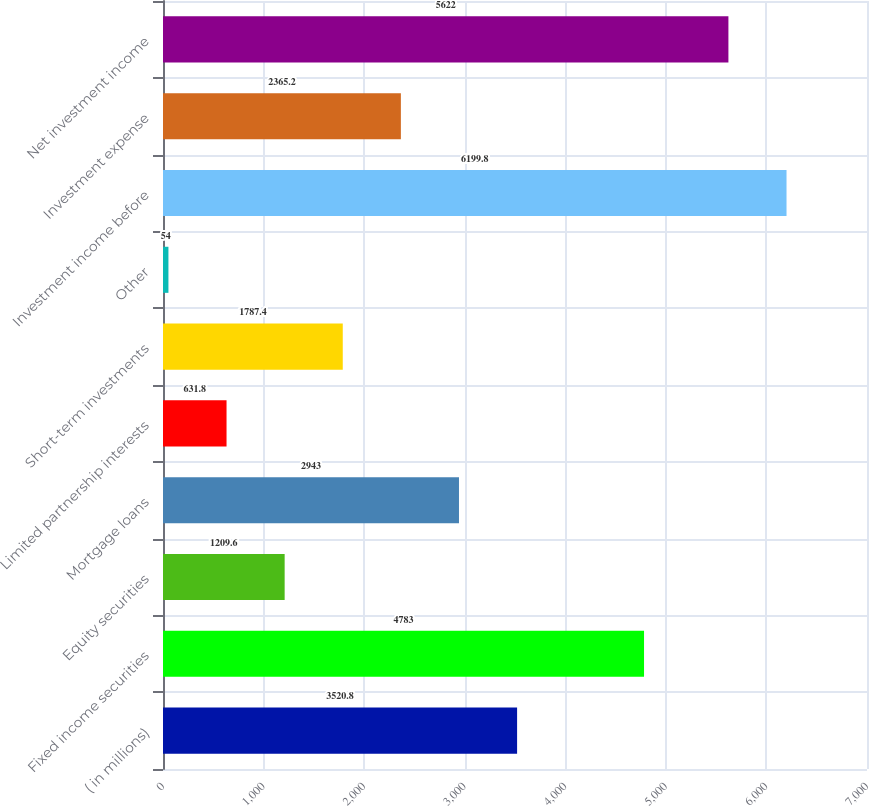Convert chart to OTSL. <chart><loc_0><loc_0><loc_500><loc_500><bar_chart><fcel>( in millions)<fcel>Fixed income securities<fcel>Equity securities<fcel>Mortgage loans<fcel>Limited partnership interests<fcel>Short-term investments<fcel>Other<fcel>Investment income before<fcel>Investment expense<fcel>Net investment income<nl><fcel>3520.8<fcel>4783<fcel>1209.6<fcel>2943<fcel>631.8<fcel>1787.4<fcel>54<fcel>6199.8<fcel>2365.2<fcel>5622<nl></chart> 